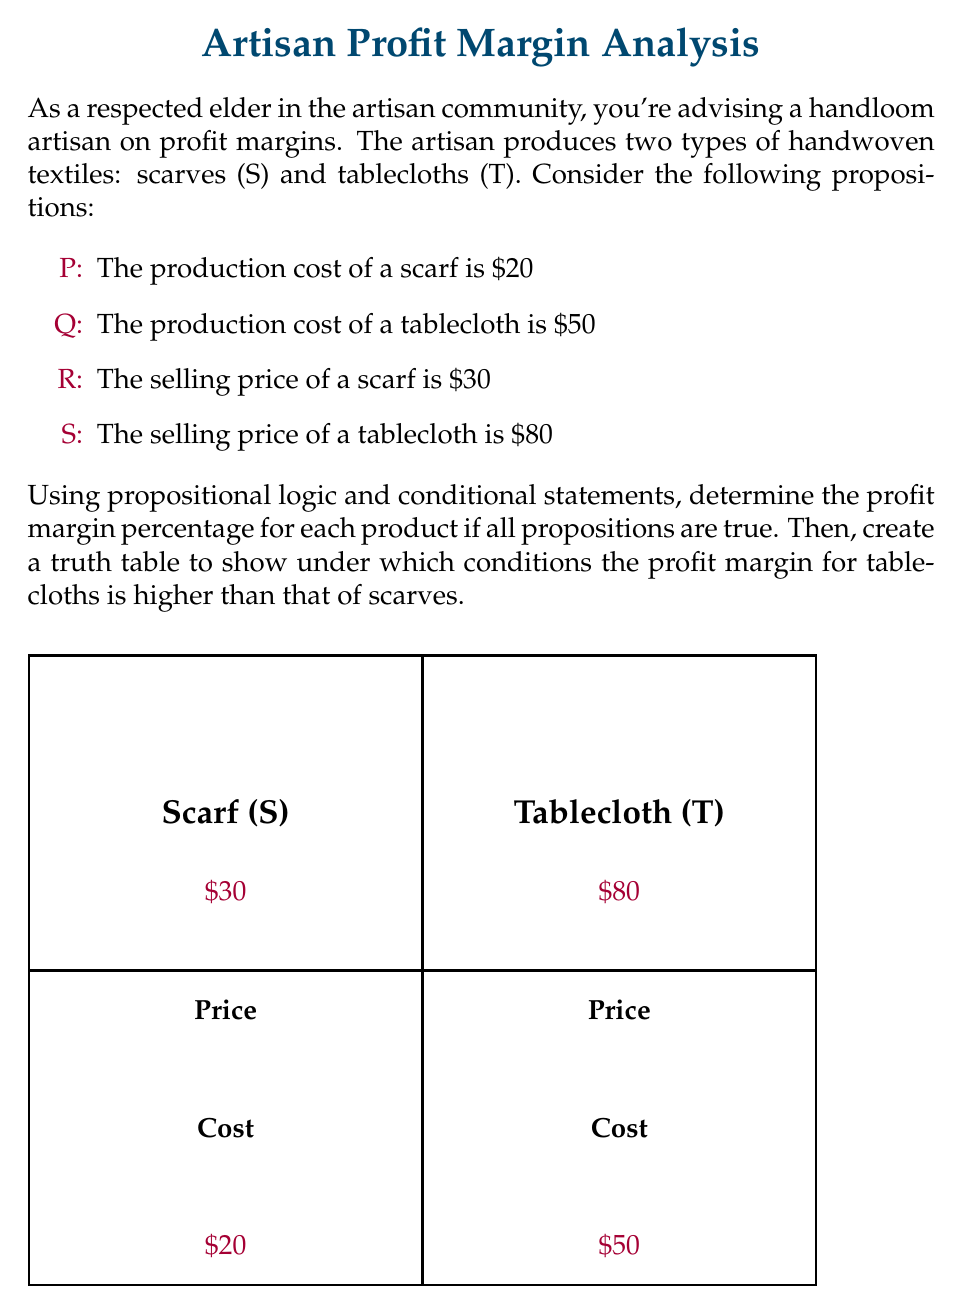Could you help me with this problem? Let's approach this problem step-by-step:

1) First, let's calculate the profit margins for each product:

   For scarves (S):
   Profit = Selling price - Production cost = $30 - $20 = $10
   Profit Margin % = (Profit / Selling price) * 100 = ($10 / $30) * 100 = 33.33%

   For tablecloths (T):
   Profit = Selling price - Production cost = $80 - $50 = $30
   Profit Margin % = (Profit / Selling price) * 100 = ($30 / $80) * 100 = 37.5%

2) Now, let's express these as conditional statements:

   If P and R, then profit margin for S is 33.33%
   If Q and S, then profit margin for T is 37.5%

3) To determine when the profit margin for T is higher than S, we need to create a truth table:

   Let's define a new proposition:
   H: The profit margin for T is higher than S

   Truth Table:
   P | Q | R | S | H
   ----------------
   T | T | T | T | T  (This is the case we calculated above)
   T | T | T | F | F  (If S is false, T's selling price is too low for profit)
   T | T | F | T | T  (If R is false, S's profit margin decreases)
   T | T | F | F | F  (Both have low selling prices)
   T | F | T | T | T  (If Q is false, T's profit margin increases)
   T | F | T | F | T  (T's cost is lower, so even with lower price, margin is higher)
   T | F | F | T | T  (T's cost is lower, S's price is lower)
   T | F | F | F | T  (T's cost is lower, both prices are lower)
   F | T | T | T | F  (If P is false, S's profit margin increases)
   F | T | T | F | F  (S's cost is lower, T's price is lower)
   F | T | F | T | F  (S's cost is lower, S's price is lower)
   F | T | F | F | F  (S's cost is lower, both prices are lower)
   F | F | T | T | I  (Insufficient information to compare)
   F | F | T | F | I  (Insufficient information to compare)
   F | F | F | T | I  (Insufficient information to compare)
   F | F | F | F | I  (Insufficient information to compare)

   Where I means "Insufficient information"

4) From this truth table, we can derive the logical statement for when H is true:

   $H \iff (P \land Q \land R \land S) \lor (P \land Q \land \neg R \land S) \lor (P \land \neg Q \land R \land S) \lor (P \land \neg Q \land R \land \neg S) \lor (P \land \neg Q \land \neg R \land S) \lor (P \land \neg Q \land \neg R \land \neg S)$

This can be simplified to:

   $H \iff P \land [(Q \land S) \lor \neg Q]$
Answer: $H \iff P \land [(Q \land S) \lor \neg Q]$ 